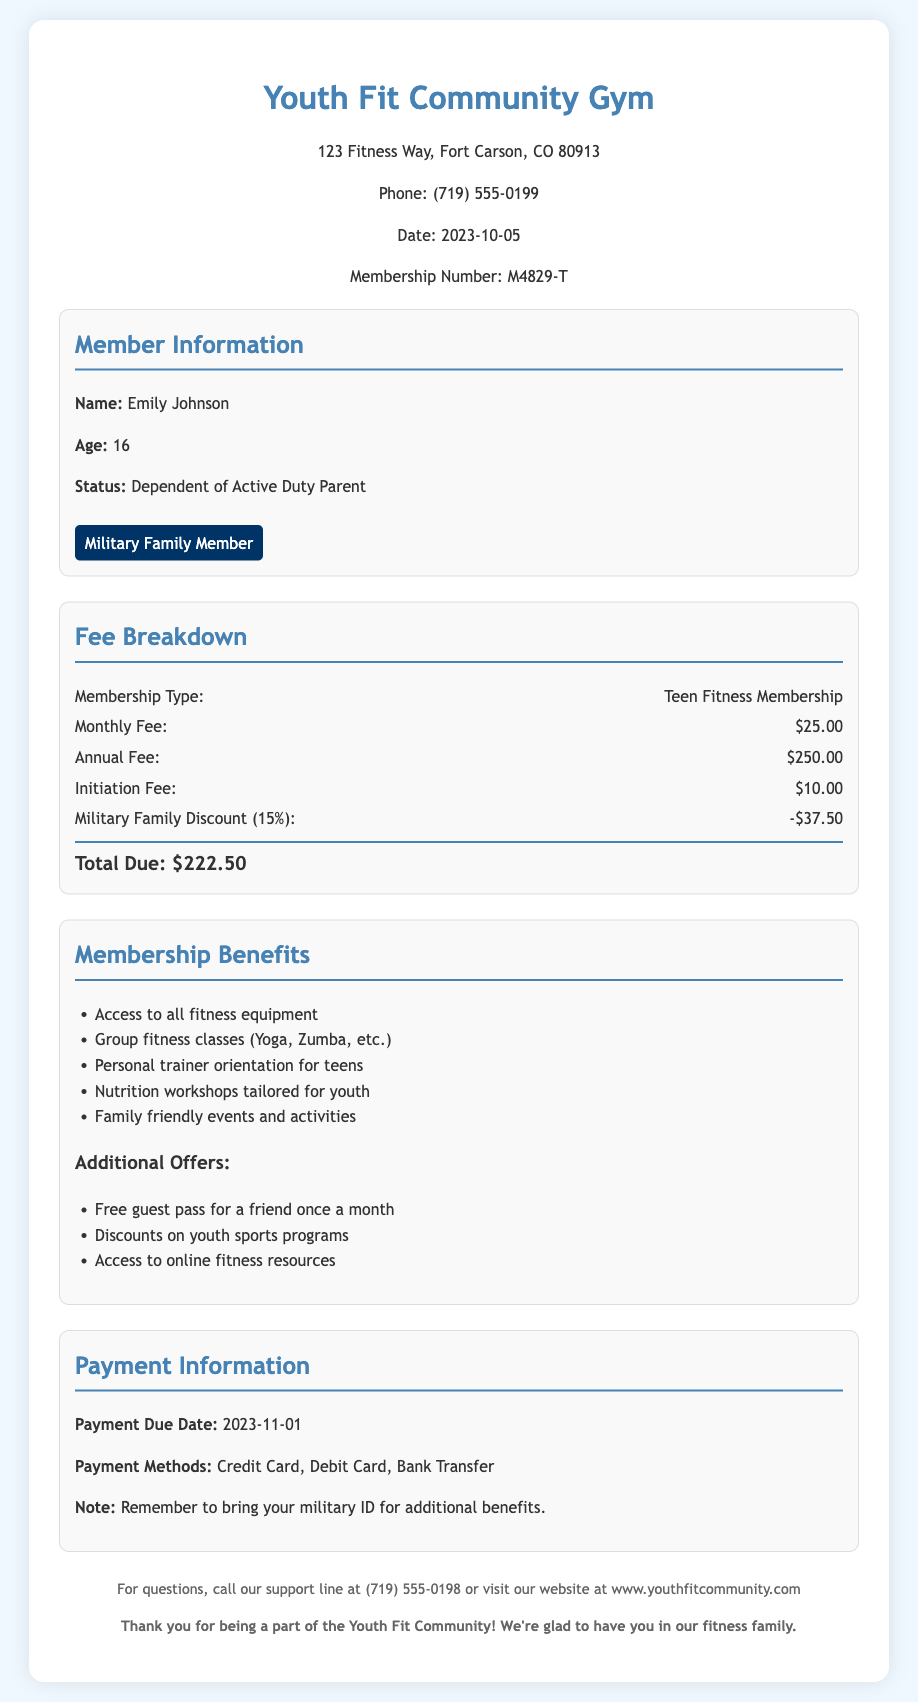What is the membership number? The membership number is provided in the document as M4829-T.
Answer: M4829-T What is the monthly fee for the Teen Fitness Membership? The document specifies the monthly fee as $25.00.
Answer: $25.00 What is the total due after the military family discount? The total due is calculated after applying the military family discount and is stated as $222.50.
Answer: $222.50 What is the age of the member? The document indicates that the member, Emily Johnson, is 16 years old.
Answer: 16 What type of workshops are offered as part of the membership benefits? The membership benefits list includes nutrition workshops tailored for youth.
Answer: Nutrition workshops tailored for youth How much is the initiation fee? The document lists the initiation fee as $10.00.
Answer: $10.00 What discount percentage is provided for military families? The document mentions a military family discount of 15%.
Answer: 15% When is the payment due date? The payment due date is explicitly stated in the document as November 1, 2023.
Answer: November 1, 2023 What payment methods are accepted? The document lists credit card, debit card, and bank transfer as acceptable payment methods.
Answer: Credit Card, Debit Card, Bank Transfer 